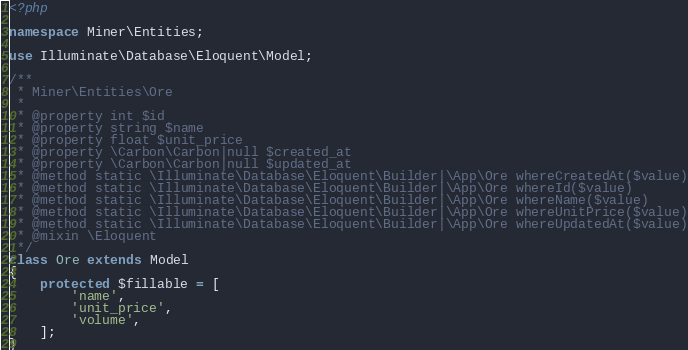<code> <loc_0><loc_0><loc_500><loc_500><_PHP_><?php

namespace Miner\Entities;

use Illuminate\Database\Eloquent\Model;

/**
 * Miner\Entities\Ore
 *
 * @property int $id
 * @property string $name
 * @property float $unit_price
 * @property \Carbon\Carbon|null $created_at
 * @property \Carbon\Carbon|null $updated_at
 * @method static \Illuminate\Database\Eloquent\Builder|\App\Ore whereCreatedAt($value)
 * @method static \Illuminate\Database\Eloquent\Builder|\App\Ore whereId($value)
 * @method static \Illuminate\Database\Eloquent\Builder|\App\Ore whereName($value)
 * @method static \Illuminate\Database\Eloquent\Builder|\App\Ore whereUnitPrice($value)
 * @method static \Illuminate\Database\Eloquent\Builder|\App\Ore whereUpdatedAt($value)
 * @mixin \Eloquent
 */
class Ore extends Model
{
    protected $fillable = [
        'name',
        'unit_price',
        'volume',
    ];
}
</code> 